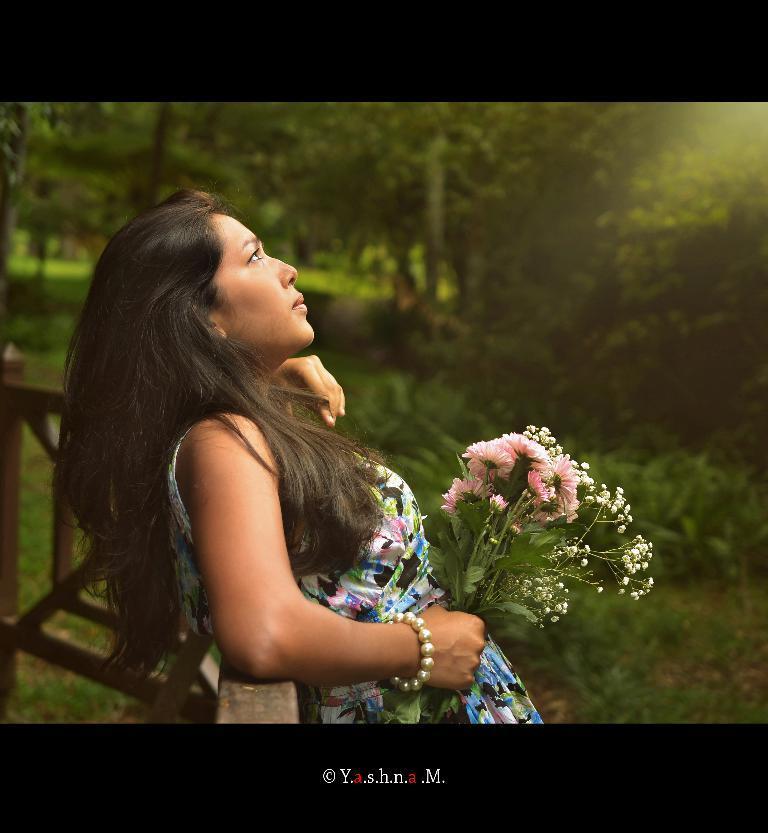Can you describe this image briefly? There is one women standing in the middle of this image is holding some flowers. There are some trees in the background. There is a fencing wall on the left side of this image. There is some text written at the bottom of this image. 